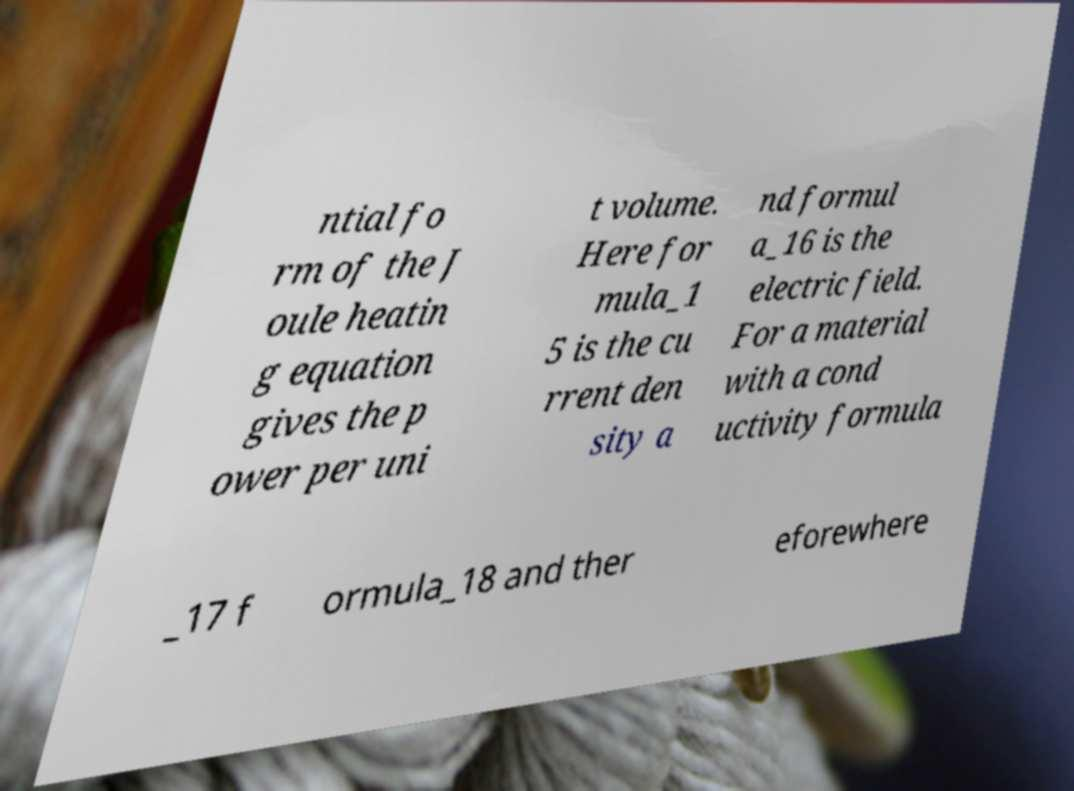Could you assist in decoding the text presented in this image and type it out clearly? ntial fo rm of the J oule heatin g equation gives the p ower per uni t volume. Here for mula_1 5 is the cu rrent den sity a nd formul a_16 is the electric field. For a material with a cond uctivity formula _17 f ormula_18 and ther eforewhere 